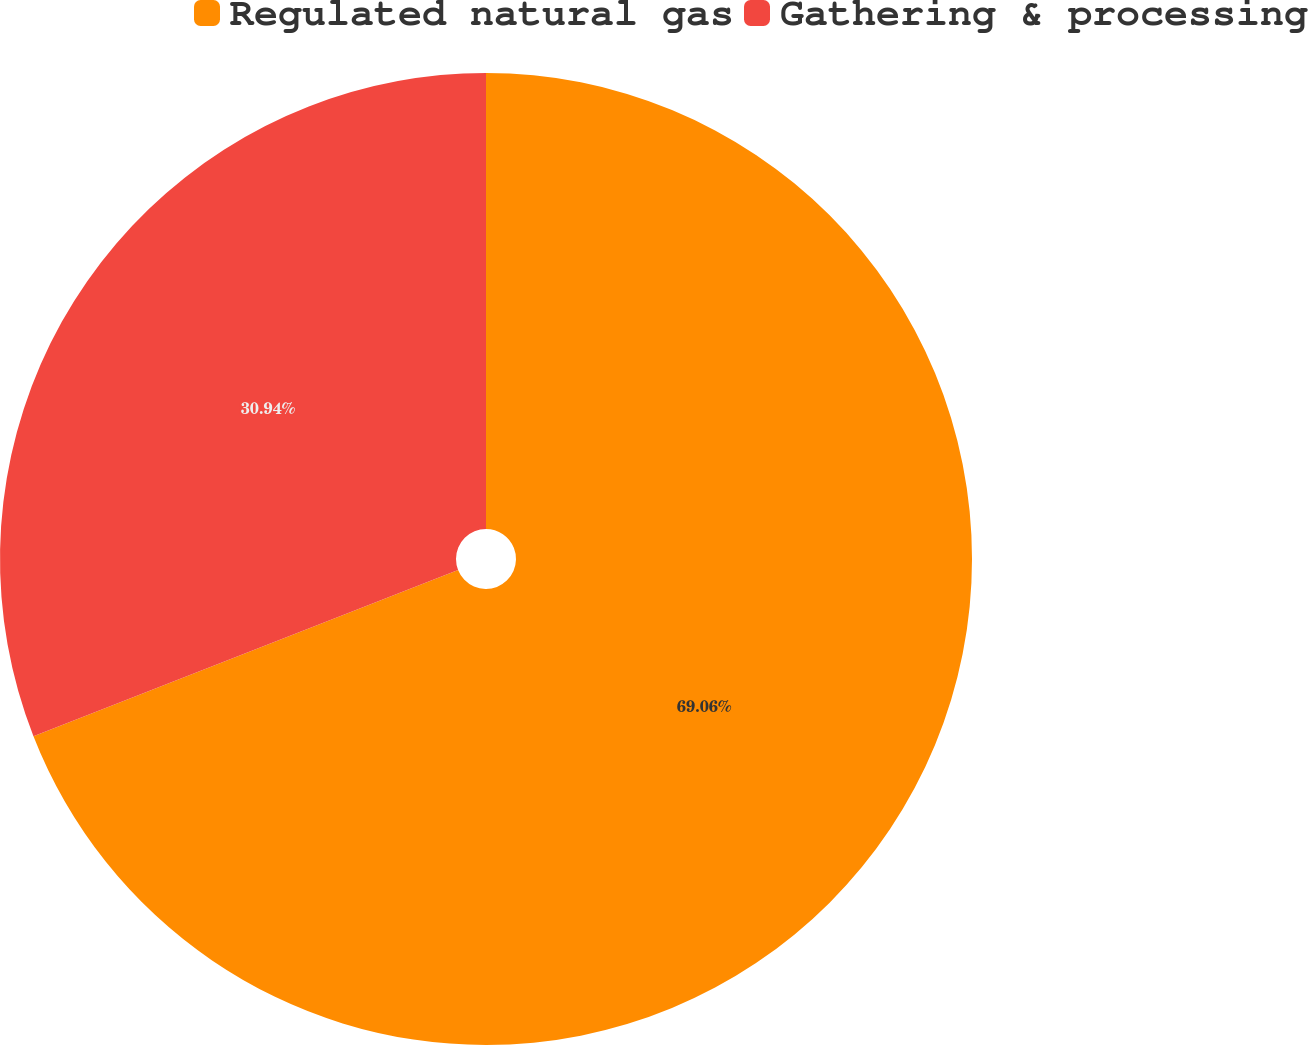Convert chart. <chart><loc_0><loc_0><loc_500><loc_500><pie_chart><fcel>Regulated natural gas<fcel>Gathering & processing<nl><fcel>69.06%<fcel>30.94%<nl></chart> 